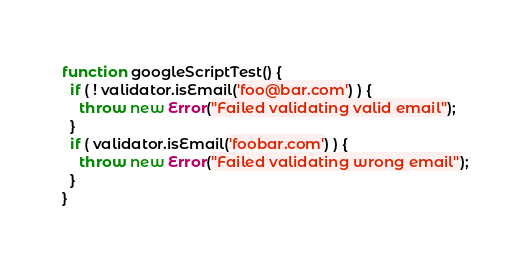Convert code to text. <code><loc_0><loc_0><loc_500><loc_500><_JavaScript_>function googleScriptTest() {
  if ( ! validator.isEmail('foo@bar.com') ) {
    throw new Error("Failed validating valid email");
  }
  if ( validator.isEmail('foobar.com') ) {
    throw new Error("Failed validating wrong email");
  }
}
</code> 